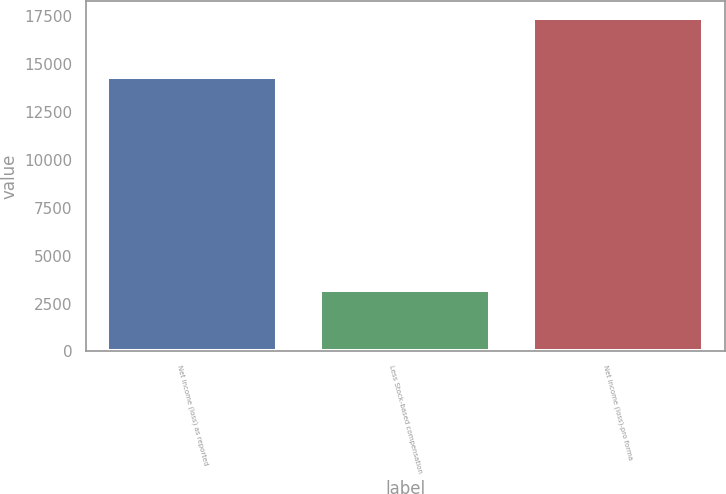Convert chart to OTSL. <chart><loc_0><loc_0><loc_500><loc_500><bar_chart><fcel>Net income (loss) as reported<fcel>Less Stock-based compensation<fcel>Net income (loss)-pro forma<nl><fcel>14358<fcel>3194<fcel>17429<nl></chart> 